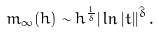Convert formula to latex. <formula><loc_0><loc_0><loc_500><loc_500>m _ { \infty } ( h ) \sim h ^ { \frac { 1 } { \delta } } | \ln { | t | } | ^ { \hat { \delta } } \, .</formula> 